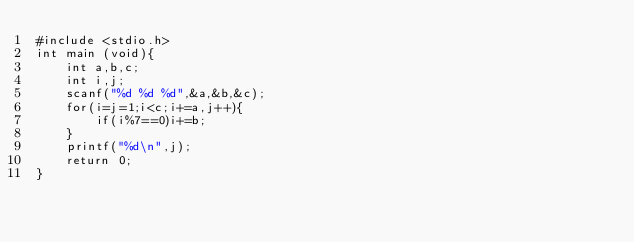Convert code to text. <code><loc_0><loc_0><loc_500><loc_500><_C#_>#include <stdio.h>
int main (void){
	int a,b,c;
	int i,j;
	scanf("%d %d %d",&a,&b,&c);
	for(i=j=1;i<c;i+=a,j++){
		if(i%7==0)i+=b;
	}
	printf("%d\n",j);
	return 0;
}

</code> 